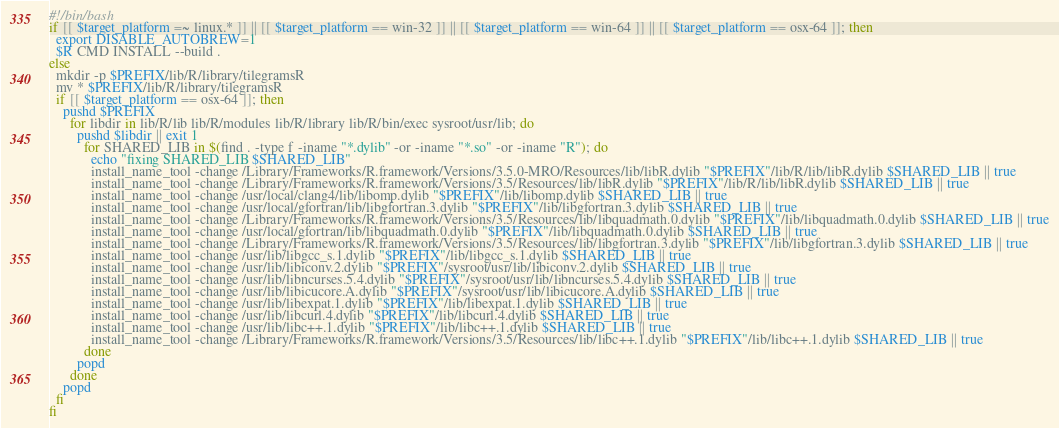Convert code to text. <code><loc_0><loc_0><loc_500><loc_500><_Bash_>#!/bin/bash
if [[ $target_platform =~ linux.* ]] || [[ $target_platform == win-32 ]] || [[ $target_platform == win-64 ]] || [[ $target_platform == osx-64 ]]; then
  export DISABLE_AUTOBREW=1
  $R CMD INSTALL --build .
else
  mkdir -p $PREFIX/lib/R/library/tilegramsR
  mv * $PREFIX/lib/R/library/tilegramsR
  if [[ $target_platform == osx-64 ]]; then
    pushd $PREFIX
      for libdir in lib/R/lib lib/R/modules lib/R/library lib/R/bin/exec sysroot/usr/lib; do
        pushd $libdir || exit 1
          for SHARED_LIB in $(find . -type f -iname "*.dylib" -or -iname "*.so" -or -iname "R"); do
            echo "fixing SHARED_LIB $SHARED_LIB"
            install_name_tool -change /Library/Frameworks/R.framework/Versions/3.5.0-MRO/Resources/lib/libR.dylib "$PREFIX"/lib/R/lib/libR.dylib $SHARED_LIB || true
            install_name_tool -change /Library/Frameworks/R.framework/Versions/3.5/Resources/lib/libR.dylib "$PREFIX"/lib/R/lib/libR.dylib $SHARED_LIB || true
            install_name_tool -change /usr/local/clang4/lib/libomp.dylib "$PREFIX"/lib/libomp.dylib $SHARED_LIB || true
            install_name_tool -change /usr/local/gfortran/lib/libgfortran.3.dylib "$PREFIX"/lib/libgfortran.3.dylib $SHARED_LIB || true
            install_name_tool -change /Library/Frameworks/R.framework/Versions/3.5/Resources/lib/libquadmath.0.dylib "$PREFIX"/lib/libquadmath.0.dylib $SHARED_LIB || true
            install_name_tool -change /usr/local/gfortran/lib/libquadmath.0.dylib "$PREFIX"/lib/libquadmath.0.dylib $SHARED_LIB || true
            install_name_tool -change /Library/Frameworks/R.framework/Versions/3.5/Resources/lib/libgfortran.3.dylib "$PREFIX"/lib/libgfortran.3.dylib $SHARED_LIB || true
            install_name_tool -change /usr/lib/libgcc_s.1.dylib "$PREFIX"/lib/libgcc_s.1.dylib $SHARED_LIB || true
            install_name_tool -change /usr/lib/libiconv.2.dylib "$PREFIX"/sysroot/usr/lib/libiconv.2.dylib $SHARED_LIB || true
            install_name_tool -change /usr/lib/libncurses.5.4.dylib "$PREFIX"/sysroot/usr/lib/libncurses.5.4.dylib $SHARED_LIB || true
            install_name_tool -change /usr/lib/libicucore.A.dylib "$PREFIX"/sysroot/usr/lib/libicucore.A.dylib $SHARED_LIB || true
            install_name_tool -change /usr/lib/libexpat.1.dylib "$PREFIX"/lib/libexpat.1.dylib $SHARED_LIB || true
            install_name_tool -change /usr/lib/libcurl.4.dylib "$PREFIX"/lib/libcurl.4.dylib $SHARED_LIB || true
            install_name_tool -change /usr/lib/libc++.1.dylib "$PREFIX"/lib/libc++.1.dylib $SHARED_LIB || true
            install_name_tool -change /Library/Frameworks/R.framework/Versions/3.5/Resources/lib/libc++.1.dylib "$PREFIX"/lib/libc++.1.dylib $SHARED_LIB || true
          done
        popd
      done
    popd
  fi
fi
</code> 